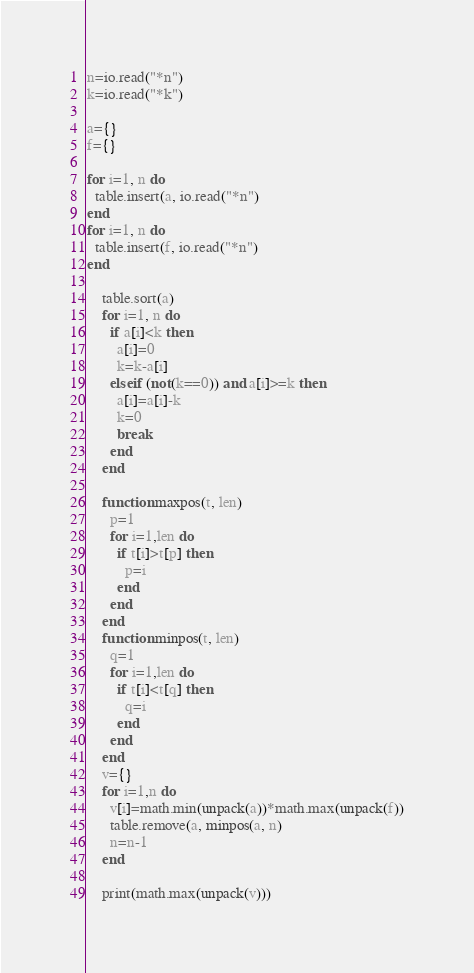<code> <loc_0><loc_0><loc_500><loc_500><_Lua_>n=io.read("*n")
k=io.read("*k")

a={}
f={}

for i=1, n do
  table.insert(a, io.read("*n")
end
for i=1, n do
  table.insert(f, io.read("*n")
end
    
    table.sort(a)
    for i=1, n do
      if a[i]<k then
        a[i]=0
        k=k-a[i]
      elseif (not(k==0)) and a[i]>=k then
        a[i]=a[i]-k
        k=0
        break
      end
    end
    
    function maxpos(t, len)
      p=1
      for i=1,len do
        if t[i]>t[p] then
          p=i
        end
      end
    end
    function minpos(t, len)
      q=1
      for i=1,len do
        if t[i]<t[q] then
          q=i
        end
      end
    end
    v={}
    for i=1,n do
      v[i]=math.min(unpack(a))*math.max(unpack(f))
      table.remove(a, minpos(a, n)
      n=n-1
    end
      
    print(math.max(unpack(v)))</code> 